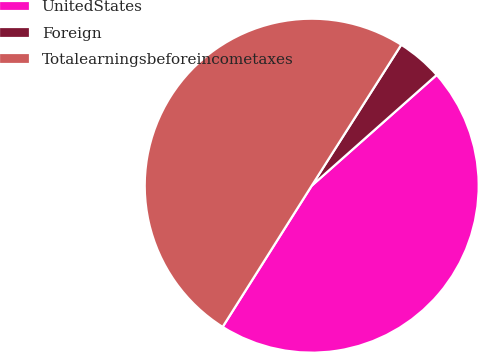Convert chart to OTSL. <chart><loc_0><loc_0><loc_500><loc_500><pie_chart><fcel>UnitedStates<fcel>Foreign<fcel>Totalearningsbeforeincometaxes<nl><fcel>45.5%<fcel>4.45%<fcel>50.05%<nl></chart> 